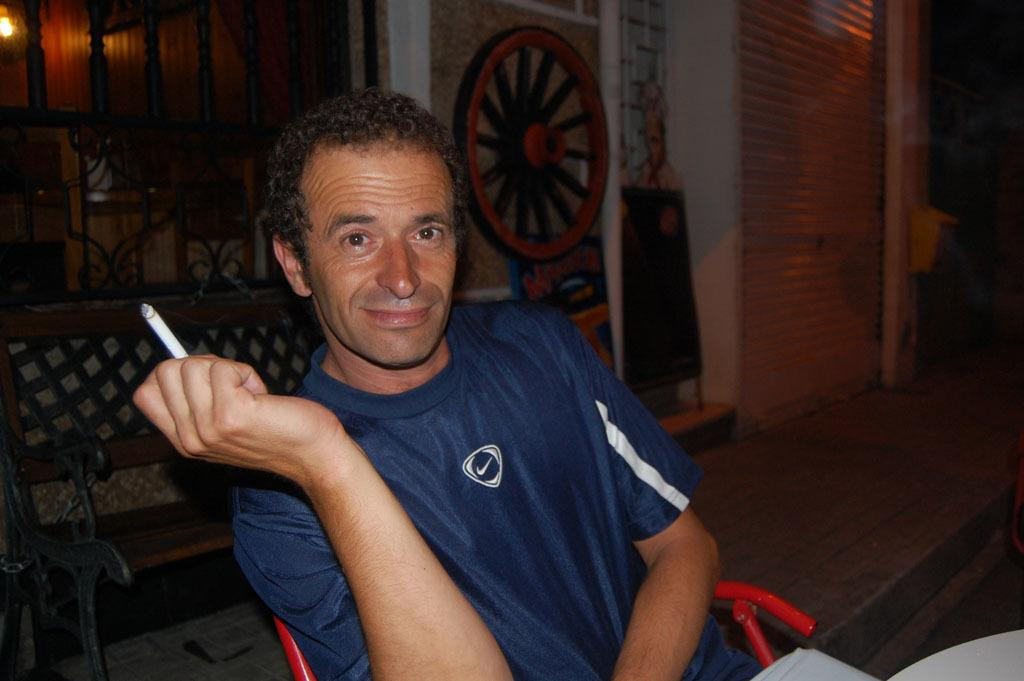What is the main subject of the image? There is a person in the image. What is the person wearing? The person is wearing a blue shirt. What is the person doing in the image? The person is sitting in a chair. What is the person holding in their hand? The person is holding a cigarette in their hand. What other objects can be seen in the image? There are other objects visible in the image. What type of mint is growing on the person's shirt in the image? There is no mint growing on the person's shirt in the image. How many screws can be seen holding the chair together in the image? There is no information about screws or the chair's construction in the image. 